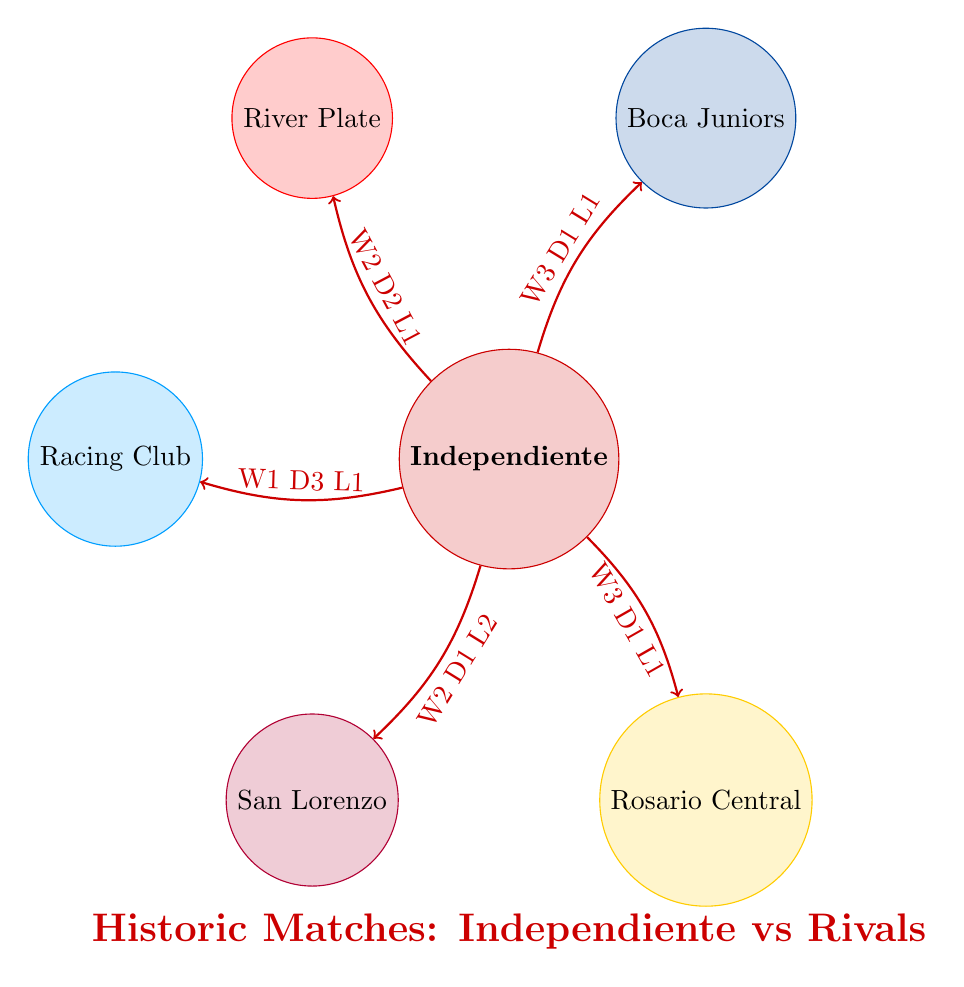What is the total number of matches played between Independiente and Boca Juniors? The diagram indicates that the link between Independiente and Boca Juniors has a value labeled "5", representing the total matches played against each other.
Answer: 5 How many wins does Independiente have against Racing Club? From the diagram, the link to Racing Club shows "W1" which indicates that Independiente won once in their matchups against Racing Club.
Answer: 1 Which rival has the most wins against Independiente? Analyzing the match links, Racing Club has the least wins for Independiente with only 1 win shown in its link. All others have more than this. Thus, Racing Club has the most wins among rival teams.
Answer: Racing Club How many draws have occurred between Independiente and River Plate? The link to River Plate indicates "D2", revealing that there have been two draws between Independiente and River Plate during their matches.
Answer: 2 Which team has the highest wins against Independiente? Examining the win counts, Boca Juniors and Rosario Central each have 3 wins while Racing Club has only 1 win. Therefore, Boca Juniors and Rosario Central can be considered as having the highest wins.
Answer: Boca Juniors and Rosario Central What is the total number of losses for Independiente against San Lorenzo? The diagram shows the loss count against San Lorenzo as indicated by "L2" in the link to San Lorenzo. Thus, Independiente lost two matches against San Lorenzo.
Answer: 2 How many total teams are displayed in the diagram? The diagram lists six teams total: Independiente, Boca Juniors, River Plate, Racing Club, San Lorenzo, and Rosario Central. Therefore, when counting these nodes, the total ends up as six.
Answer: 6 Which rival shows the lowest number of draws with Independiente? Among the links from Independiente, Racing Club shows "D3", indicating three draws, while the rest show less; thus, Racing Club also has the most draws. Therefore, the rival with the lowest draws against Independiente must be San Lorenzo with only 1 draw.
Answer: San Lorenzo What color represents Boca Juniors in the diagram? The color for each team is defined by the fill of the respective nodes. Boca Juniors is indicated by blue color, specifically represented as "bocaBlue".
Answer: Blue 